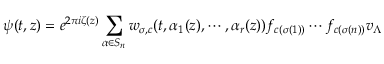<formula> <loc_0><loc_0><loc_500><loc_500>\psi ( t , z ) = e ^ { 2 \pi i \zeta ( z ) } \sum _ { \alpha \in S _ { n } } w _ { \sigma , c } ( t , \alpha _ { 1 } ( z ) , \cdots , \alpha _ { r } ( z ) ) f _ { c ( \sigma ( 1 ) ) } \cdots f _ { c ( \sigma ( n ) ) } v _ { \Lambda }</formula> 